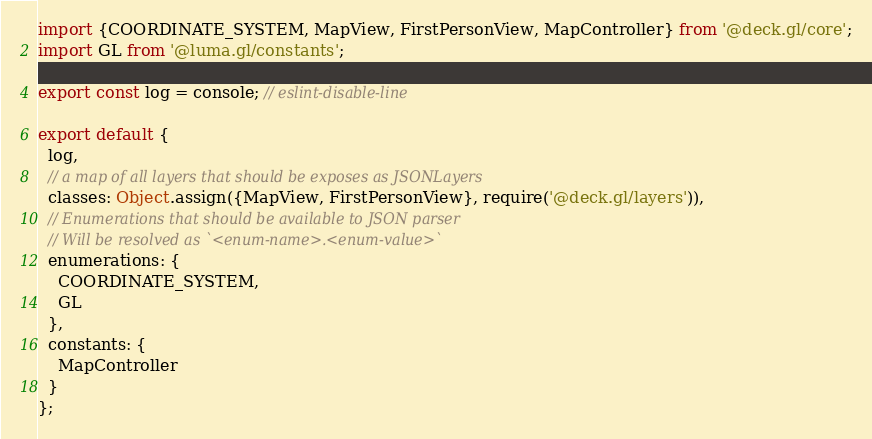<code> <loc_0><loc_0><loc_500><loc_500><_JavaScript_>import {COORDINATE_SYSTEM, MapView, FirstPersonView, MapController} from '@deck.gl/core';
import GL from '@luma.gl/constants';

export const log = console; // eslint-disable-line

export default {
  log,
  // a map of all layers that should be exposes as JSONLayers
  classes: Object.assign({MapView, FirstPersonView}, require('@deck.gl/layers')),
  // Enumerations that should be available to JSON parser
  // Will be resolved as `<enum-name>.<enum-value>`
  enumerations: {
    COORDINATE_SYSTEM,
    GL
  },
  constants: {
    MapController
  }
};
</code> 